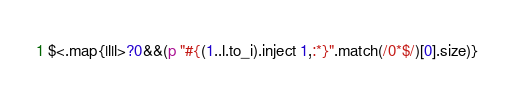<code> <loc_0><loc_0><loc_500><loc_500><_Ruby_>$<.map{|l|l>?0&&(p "#{(1..l.to_i).inject 1,:*}".match(/0*$/)[0].size)}</code> 